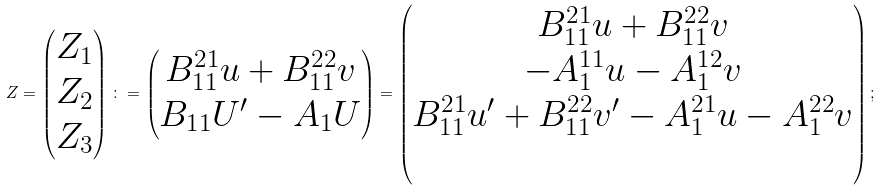<formula> <loc_0><loc_0><loc_500><loc_500>Z = \begin{pmatrix} Z _ { 1 } \\ Z _ { 2 } \\ Z _ { 3 } \end{pmatrix} \colon = \begin{pmatrix} B _ { 1 1 } ^ { 2 1 } u + B _ { 1 1 } ^ { 2 2 } v \\ B _ { 1 1 } U ^ { \prime } - A _ { 1 } U \end{pmatrix} = \begin{pmatrix} B _ { 1 1 } ^ { 2 1 } u + B _ { 1 1 } ^ { 2 2 } v \\ - A _ { 1 } ^ { 1 1 } u - A _ { 1 } ^ { 1 2 } v \\ B _ { 1 1 } ^ { 2 1 } u ^ { \prime } + B _ { 1 1 } ^ { 2 2 } v ^ { \prime } - A _ { 1 } ^ { 2 1 } u - A _ { 1 } ^ { 2 2 } v \\ \\ \end{pmatrix} ;</formula> 